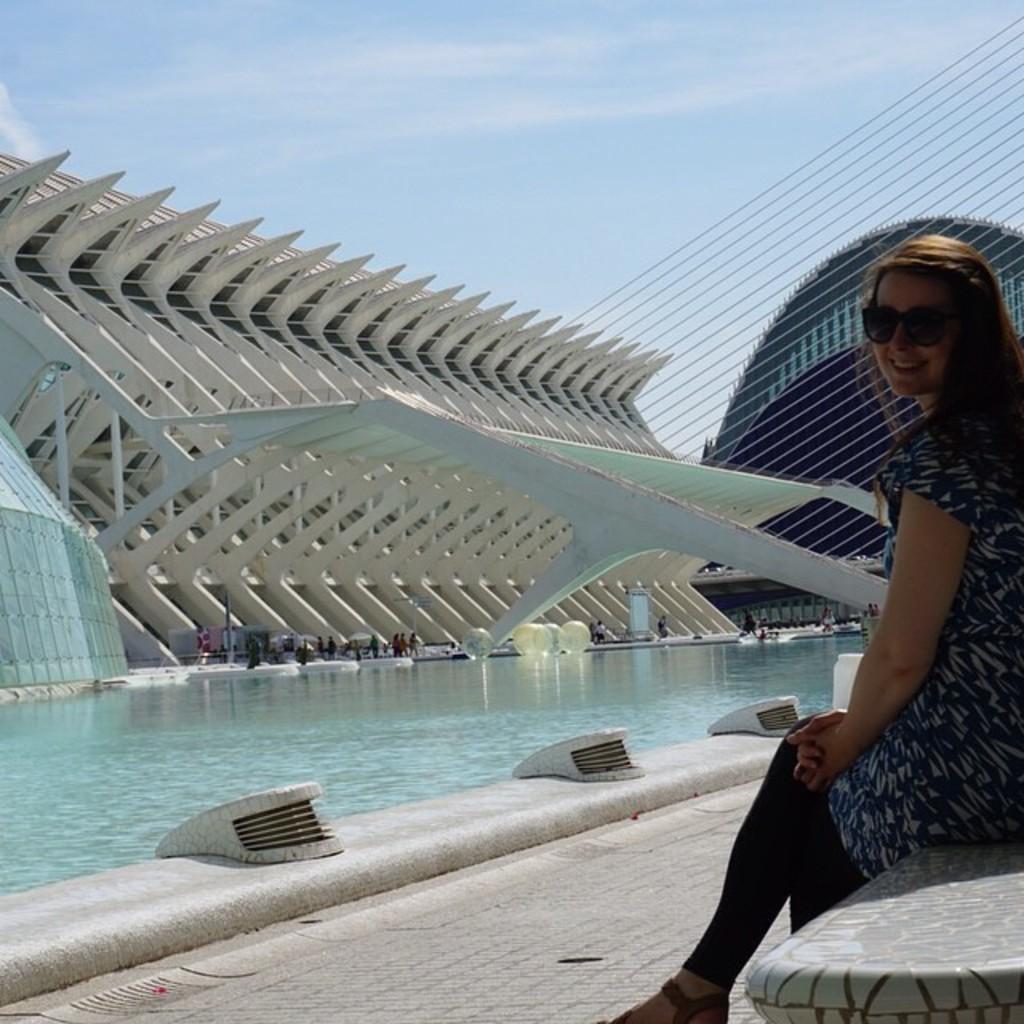Can you describe this image briefly? In this image I can see a woman wearing black and white colored dress is sitting on a bench. In the background I can see a swimming pool, few persons, few buildings and the sky. 